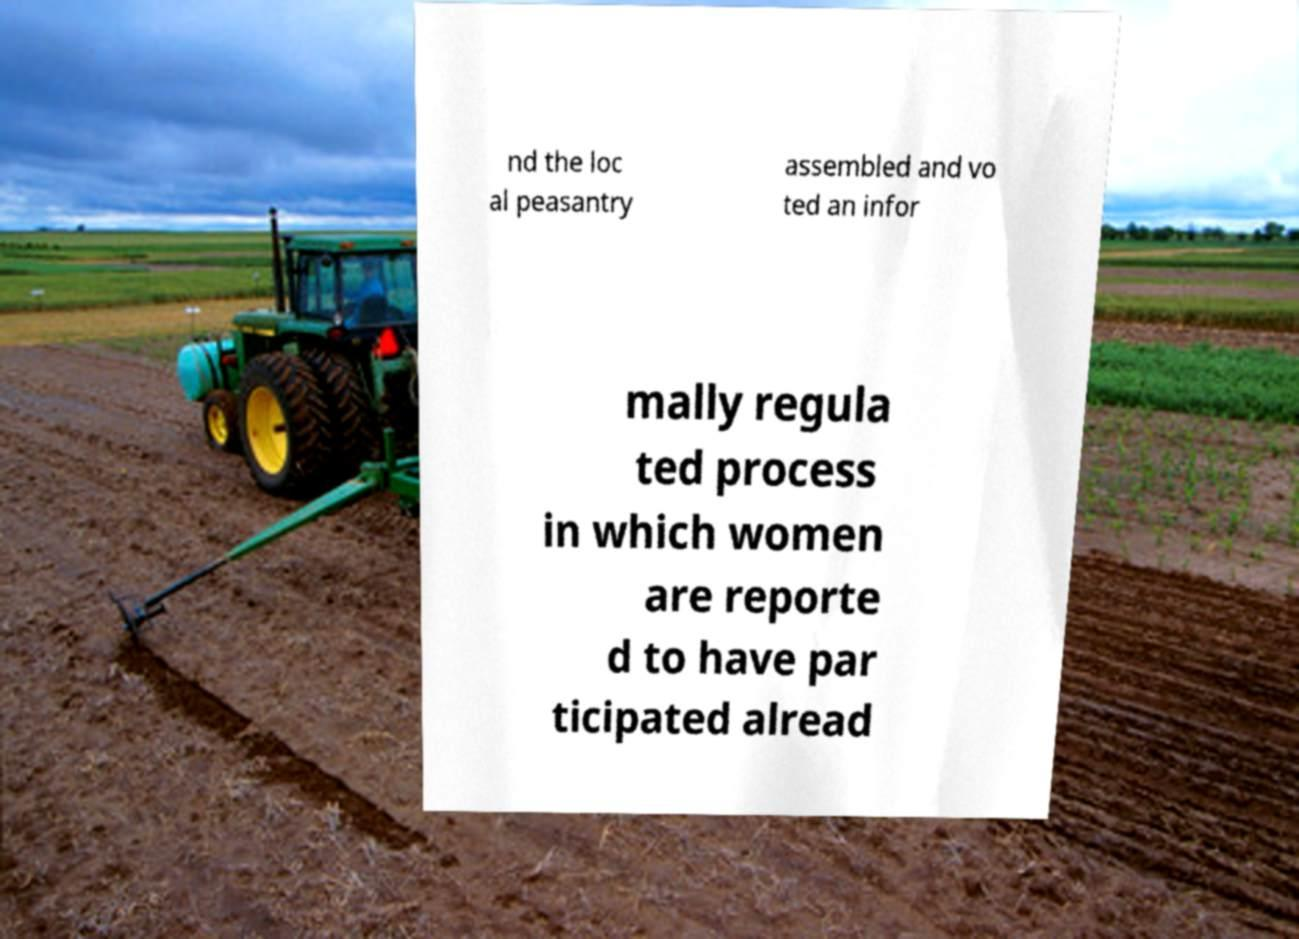Please read and relay the text visible in this image. What does it say? nd the loc al peasantry assembled and vo ted an infor mally regula ted process in which women are reporte d to have par ticipated alread 